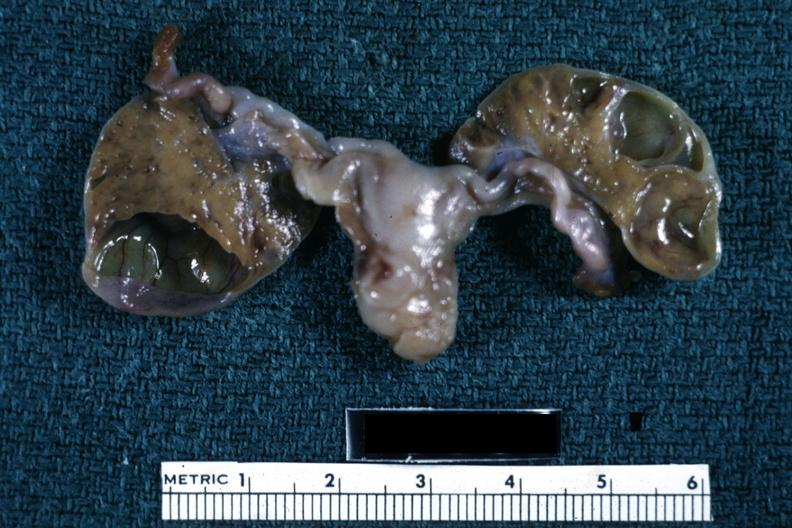s female reproductive present?
Answer the question using a single word or phrase. Yes 